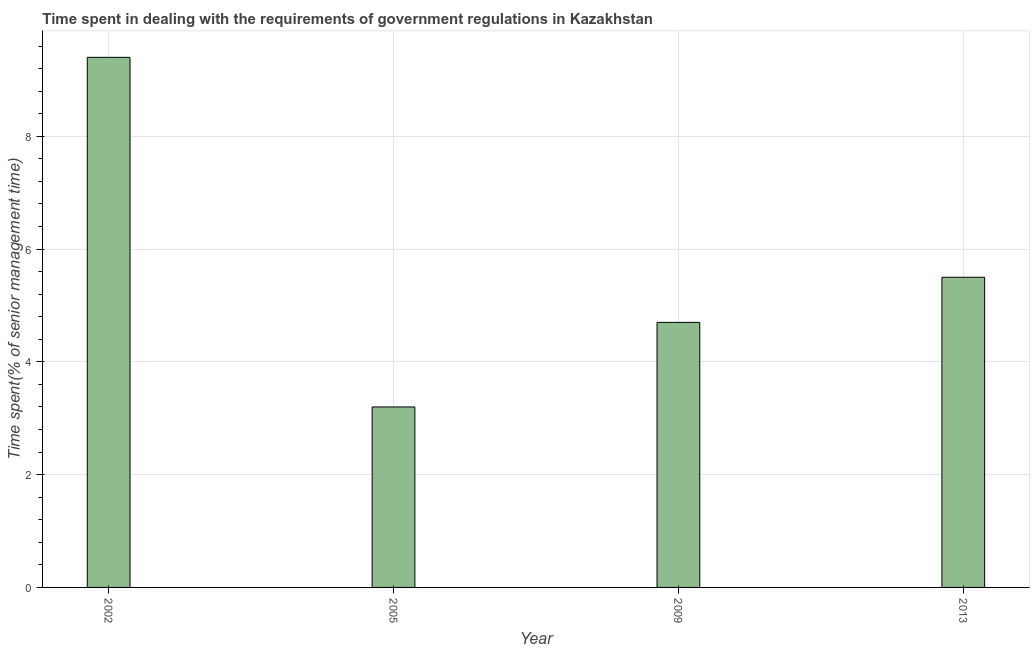Does the graph contain any zero values?
Keep it short and to the point. No. What is the title of the graph?
Ensure brevity in your answer.  Time spent in dealing with the requirements of government regulations in Kazakhstan. What is the label or title of the X-axis?
Your response must be concise. Year. What is the label or title of the Y-axis?
Your answer should be compact. Time spent(% of senior management time). What is the time spent in dealing with government regulations in 2009?
Keep it short and to the point. 4.7. Across all years, what is the maximum time spent in dealing with government regulations?
Your response must be concise. 9.4. Across all years, what is the minimum time spent in dealing with government regulations?
Your answer should be compact. 3.2. In which year was the time spent in dealing with government regulations maximum?
Give a very brief answer. 2002. In which year was the time spent in dealing with government regulations minimum?
Give a very brief answer. 2005. What is the sum of the time spent in dealing with government regulations?
Ensure brevity in your answer.  22.8. What is the difference between the time spent in dealing with government regulations in 2002 and 2009?
Ensure brevity in your answer.  4.7. What is the average time spent in dealing with government regulations per year?
Offer a very short reply. 5.7. In how many years, is the time spent in dealing with government regulations greater than 6.4 %?
Give a very brief answer. 1. Do a majority of the years between 2013 and 2005 (inclusive) have time spent in dealing with government regulations greater than 4.4 %?
Provide a succinct answer. Yes. What is the ratio of the time spent in dealing with government regulations in 2005 to that in 2013?
Your answer should be very brief. 0.58. Is the time spent in dealing with government regulations in 2002 less than that in 2009?
Keep it short and to the point. No. Is the difference between the time spent in dealing with government regulations in 2009 and 2013 greater than the difference between any two years?
Offer a very short reply. No. What is the difference between the highest and the second highest time spent in dealing with government regulations?
Your answer should be very brief. 3.9. Is the sum of the time spent in dealing with government regulations in 2002 and 2005 greater than the maximum time spent in dealing with government regulations across all years?
Offer a terse response. Yes. In how many years, is the time spent in dealing with government regulations greater than the average time spent in dealing with government regulations taken over all years?
Your answer should be compact. 1. How many bars are there?
Your answer should be very brief. 4. How many years are there in the graph?
Ensure brevity in your answer.  4. What is the difference between two consecutive major ticks on the Y-axis?
Your answer should be compact. 2. Are the values on the major ticks of Y-axis written in scientific E-notation?
Offer a very short reply. No. What is the Time spent(% of senior management time) of 2013?
Provide a succinct answer. 5.5. What is the difference between the Time spent(% of senior management time) in 2002 and 2005?
Your response must be concise. 6.2. What is the difference between the Time spent(% of senior management time) in 2002 and 2009?
Your answer should be compact. 4.7. What is the difference between the Time spent(% of senior management time) in 2005 and 2013?
Provide a short and direct response. -2.3. What is the ratio of the Time spent(% of senior management time) in 2002 to that in 2005?
Your answer should be very brief. 2.94. What is the ratio of the Time spent(% of senior management time) in 2002 to that in 2013?
Make the answer very short. 1.71. What is the ratio of the Time spent(% of senior management time) in 2005 to that in 2009?
Provide a succinct answer. 0.68. What is the ratio of the Time spent(% of senior management time) in 2005 to that in 2013?
Ensure brevity in your answer.  0.58. What is the ratio of the Time spent(% of senior management time) in 2009 to that in 2013?
Provide a succinct answer. 0.85. 